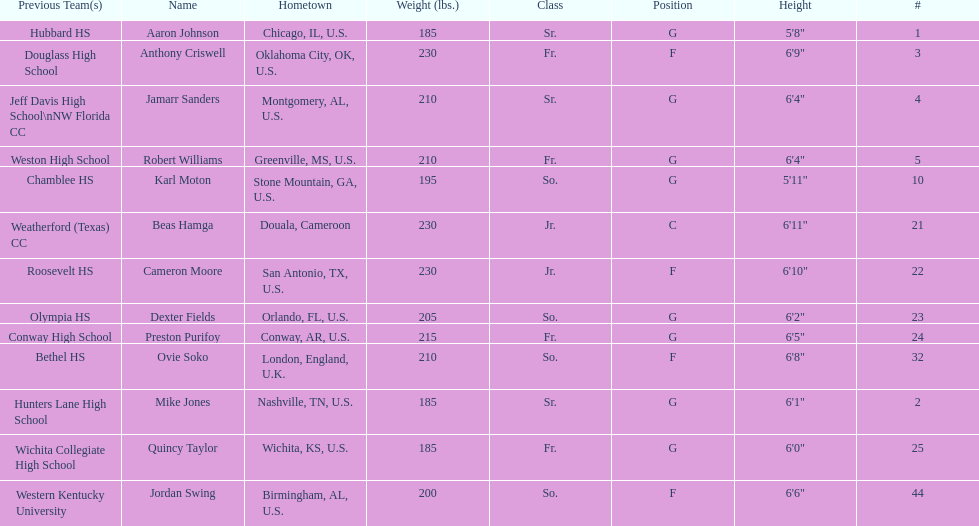What is the difference in weight between dexter fields and quincy taylor? 20. 